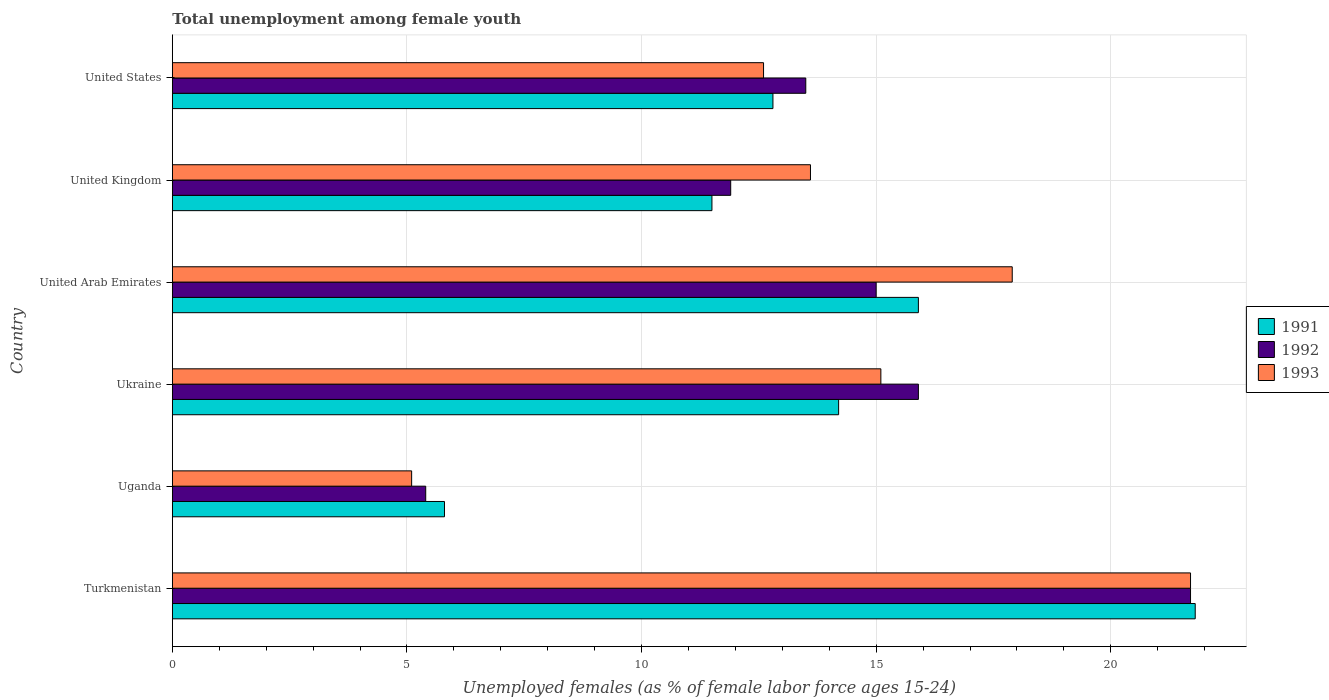Are the number of bars on each tick of the Y-axis equal?
Ensure brevity in your answer.  Yes. How many bars are there on the 5th tick from the bottom?
Give a very brief answer. 3. What is the percentage of unemployed females in in 1993 in Uganda?
Your answer should be compact. 5.1. Across all countries, what is the maximum percentage of unemployed females in in 1992?
Provide a short and direct response. 21.7. Across all countries, what is the minimum percentage of unemployed females in in 1992?
Your answer should be compact. 5.4. In which country was the percentage of unemployed females in in 1991 maximum?
Keep it short and to the point. Turkmenistan. In which country was the percentage of unemployed females in in 1991 minimum?
Provide a short and direct response. Uganda. What is the total percentage of unemployed females in in 1991 in the graph?
Keep it short and to the point. 82. What is the difference between the percentage of unemployed females in in 1992 in Turkmenistan and that in United Arab Emirates?
Keep it short and to the point. 6.7. What is the difference between the percentage of unemployed females in in 1992 in Uganda and the percentage of unemployed females in in 1991 in United Arab Emirates?
Offer a terse response. -10.5. What is the average percentage of unemployed females in in 1992 per country?
Make the answer very short. 13.9. What is the difference between the percentage of unemployed females in in 1991 and percentage of unemployed females in in 1993 in Ukraine?
Ensure brevity in your answer.  -0.9. In how many countries, is the percentage of unemployed females in in 1992 greater than 18 %?
Provide a short and direct response. 1. What is the ratio of the percentage of unemployed females in in 1991 in Ukraine to that in United States?
Your answer should be compact. 1.11. Is the percentage of unemployed females in in 1991 in Uganda less than that in United States?
Make the answer very short. Yes. What is the difference between the highest and the second highest percentage of unemployed females in in 1992?
Keep it short and to the point. 5.8. What is the difference between the highest and the lowest percentage of unemployed females in in 1991?
Keep it short and to the point. 16. In how many countries, is the percentage of unemployed females in in 1992 greater than the average percentage of unemployed females in in 1992 taken over all countries?
Your response must be concise. 3. What does the 3rd bar from the bottom in Uganda represents?
Offer a terse response. 1993. Is it the case that in every country, the sum of the percentage of unemployed females in in 1992 and percentage of unemployed females in in 1991 is greater than the percentage of unemployed females in in 1993?
Your answer should be very brief. Yes. How many bars are there?
Give a very brief answer. 18. How many countries are there in the graph?
Your response must be concise. 6. Does the graph contain any zero values?
Offer a terse response. No. How many legend labels are there?
Your response must be concise. 3. How are the legend labels stacked?
Offer a terse response. Vertical. What is the title of the graph?
Give a very brief answer. Total unemployment among female youth. What is the label or title of the X-axis?
Ensure brevity in your answer.  Unemployed females (as % of female labor force ages 15-24). What is the label or title of the Y-axis?
Make the answer very short. Country. What is the Unemployed females (as % of female labor force ages 15-24) of 1991 in Turkmenistan?
Ensure brevity in your answer.  21.8. What is the Unemployed females (as % of female labor force ages 15-24) in 1992 in Turkmenistan?
Your response must be concise. 21.7. What is the Unemployed females (as % of female labor force ages 15-24) of 1993 in Turkmenistan?
Make the answer very short. 21.7. What is the Unemployed females (as % of female labor force ages 15-24) in 1991 in Uganda?
Offer a very short reply. 5.8. What is the Unemployed females (as % of female labor force ages 15-24) in 1992 in Uganda?
Offer a very short reply. 5.4. What is the Unemployed females (as % of female labor force ages 15-24) of 1993 in Uganda?
Provide a short and direct response. 5.1. What is the Unemployed females (as % of female labor force ages 15-24) of 1991 in Ukraine?
Offer a very short reply. 14.2. What is the Unemployed females (as % of female labor force ages 15-24) in 1992 in Ukraine?
Provide a succinct answer. 15.9. What is the Unemployed females (as % of female labor force ages 15-24) of 1993 in Ukraine?
Provide a short and direct response. 15.1. What is the Unemployed females (as % of female labor force ages 15-24) in 1991 in United Arab Emirates?
Offer a terse response. 15.9. What is the Unemployed females (as % of female labor force ages 15-24) of 1992 in United Arab Emirates?
Offer a terse response. 15. What is the Unemployed females (as % of female labor force ages 15-24) in 1993 in United Arab Emirates?
Provide a short and direct response. 17.9. What is the Unemployed females (as % of female labor force ages 15-24) in 1992 in United Kingdom?
Give a very brief answer. 11.9. What is the Unemployed females (as % of female labor force ages 15-24) of 1993 in United Kingdom?
Ensure brevity in your answer.  13.6. What is the Unemployed females (as % of female labor force ages 15-24) of 1991 in United States?
Give a very brief answer. 12.8. What is the Unemployed females (as % of female labor force ages 15-24) in 1992 in United States?
Give a very brief answer. 13.5. What is the Unemployed females (as % of female labor force ages 15-24) in 1993 in United States?
Offer a very short reply. 12.6. Across all countries, what is the maximum Unemployed females (as % of female labor force ages 15-24) of 1991?
Offer a very short reply. 21.8. Across all countries, what is the maximum Unemployed females (as % of female labor force ages 15-24) of 1992?
Keep it short and to the point. 21.7. Across all countries, what is the maximum Unemployed females (as % of female labor force ages 15-24) in 1993?
Provide a succinct answer. 21.7. Across all countries, what is the minimum Unemployed females (as % of female labor force ages 15-24) of 1991?
Make the answer very short. 5.8. Across all countries, what is the minimum Unemployed females (as % of female labor force ages 15-24) in 1992?
Provide a succinct answer. 5.4. Across all countries, what is the minimum Unemployed females (as % of female labor force ages 15-24) of 1993?
Your answer should be very brief. 5.1. What is the total Unemployed females (as % of female labor force ages 15-24) of 1992 in the graph?
Make the answer very short. 83.4. What is the difference between the Unemployed females (as % of female labor force ages 15-24) of 1991 in Turkmenistan and that in Uganda?
Your answer should be very brief. 16. What is the difference between the Unemployed females (as % of female labor force ages 15-24) of 1992 in Turkmenistan and that in Uganda?
Make the answer very short. 16.3. What is the difference between the Unemployed females (as % of female labor force ages 15-24) of 1992 in Turkmenistan and that in Ukraine?
Give a very brief answer. 5.8. What is the difference between the Unemployed females (as % of female labor force ages 15-24) in 1993 in Turkmenistan and that in Ukraine?
Your response must be concise. 6.6. What is the difference between the Unemployed females (as % of female labor force ages 15-24) of 1991 in Turkmenistan and that in United Arab Emirates?
Offer a terse response. 5.9. What is the difference between the Unemployed females (as % of female labor force ages 15-24) in 1992 in Turkmenistan and that in United Arab Emirates?
Provide a succinct answer. 6.7. What is the difference between the Unemployed females (as % of female labor force ages 15-24) of 1991 in Turkmenistan and that in United Kingdom?
Offer a very short reply. 10.3. What is the difference between the Unemployed females (as % of female labor force ages 15-24) in 1992 in Turkmenistan and that in United Kingdom?
Ensure brevity in your answer.  9.8. What is the difference between the Unemployed females (as % of female labor force ages 15-24) in 1993 in Turkmenistan and that in United Kingdom?
Make the answer very short. 8.1. What is the difference between the Unemployed females (as % of female labor force ages 15-24) in 1991 in Uganda and that in Ukraine?
Your answer should be compact. -8.4. What is the difference between the Unemployed females (as % of female labor force ages 15-24) in 1993 in Uganda and that in United Arab Emirates?
Keep it short and to the point. -12.8. What is the difference between the Unemployed females (as % of female labor force ages 15-24) of 1992 in Ukraine and that in United Kingdom?
Your answer should be very brief. 4. What is the difference between the Unemployed females (as % of female labor force ages 15-24) in 1993 in Ukraine and that in United Kingdom?
Your answer should be very brief. 1.5. What is the difference between the Unemployed females (as % of female labor force ages 15-24) in 1992 in Ukraine and that in United States?
Offer a very short reply. 2.4. What is the difference between the Unemployed females (as % of female labor force ages 15-24) of 1993 in Ukraine and that in United States?
Provide a succinct answer. 2.5. What is the difference between the Unemployed females (as % of female labor force ages 15-24) in 1991 in United Arab Emirates and that in United Kingdom?
Offer a terse response. 4.4. What is the difference between the Unemployed females (as % of female labor force ages 15-24) in 1992 in United Arab Emirates and that in United Kingdom?
Ensure brevity in your answer.  3.1. What is the difference between the Unemployed females (as % of female labor force ages 15-24) in 1991 in United Arab Emirates and that in United States?
Make the answer very short. 3.1. What is the difference between the Unemployed females (as % of female labor force ages 15-24) in 1992 in United Arab Emirates and that in United States?
Make the answer very short. 1.5. What is the difference between the Unemployed females (as % of female labor force ages 15-24) of 1993 in United Arab Emirates and that in United States?
Ensure brevity in your answer.  5.3. What is the difference between the Unemployed females (as % of female labor force ages 15-24) of 1992 in United Kingdom and that in United States?
Your response must be concise. -1.6. What is the difference between the Unemployed females (as % of female labor force ages 15-24) in 1993 in United Kingdom and that in United States?
Offer a terse response. 1. What is the difference between the Unemployed females (as % of female labor force ages 15-24) of 1991 in Turkmenistan and the Unemployed females (as % of female labor force ages 15-24) of 1992 in Uganda?
Provide a succinct answer. 16.4. What is the difference between the Unemployed females (as % of female labor force ages 15-24) of 1992 in Turkmenistan and the Unemployed females (as % of female labor force ages 15-24) of 1993 in Uganda?
Your response must be concise. 16.6. What is the difference between the Unemployed females (as % of female labor force ages 15-24) in 1991 in Turkmenistan and the Unemployed females (as % of female labor force ages 15-24) in 1992 in Ukraine?
Offer a very short reply. 5.9. What is the difference between the Unemployed females (as % of female labor force ages 15-24) of 1991 in Turkmenistan and the Unemployed females (as % of female labor force ages 15-24) of 1993 in Ukraine?
Offer a very short reply. 6.7. What is the difference between the Unemployed females (as % of female labor force ages 15-24) in 1992 in Turkmenistan and the Unemployed females (as % of female labor force ages 15-24) in 1993 in Ukraine?
Your answer should be compact. 6.6. What is the difference between the Unemployed females (as % of female labor force ages 15-24) in 1991 in Turkmenistan and the Unemployed females (as % of female labor force ages 15-24) in 1992 in United Arab Emirates?
Provide a succinct answer. 6.8. What is the difference between the Unemployed females (as % of female labor force ages 15-24) in 1991 in Turkmenistan and the Unemployed females (as % of female labor force ages 15-24) in 1993 in United Arab Emirates?
Your response must be concise. 3.9. What is the difference between the Unemployed females (as % of female labor force ages 15-24) of 1992 in Turkmenistan and the Unemployed females (as % of female labor force ages 15-24) of 1993 in United Arab Emirates?
Provide a short and direct response. 3.8. What is the difference between the Unemployed females (as % of female labor force ages 15-24) in 1991 in Turkmenistan and the Unemployed females (as % of female labor force ages 15-24) in 1993 in United States?
Ensure brevity in your answer.  9.2. What is the difference between the Unemployed females (as % of female labor force ages 15-24) in 1992 in Turkmenistan and the Unemployed females (as % of female labor force ages 15-24) in 1993 in United States?
Your answer should be compact. 9.1. What is the difference between the Unemployed females (as % of female labor force ages 15-24) of 1991 in Uganda and the Unemployed females (as % of female labor force ages 15-24) of 1992 in Ukraine?
Your answer should be compact. -10.1. What is the difference between the Unemployed females (as % of female labor force ages 15-24) of 1992 in Uganda and the Unemployed females (as % of female labor force ages 15-24) of 1993 in Ukraine?
Your answer should be very brief. -9.7. What is the difference between the Unemployed females (as % of female labor force ages 15-24) of 1991 in Uganda and the Unemployed females (as % of female labor force ages 15-24) of 1992 in United Arab Emirates?
Give a very brief answer. -9.2. What is the difference between the Unemployed females (as % of female labor force ages 15-24) in 1991 in Uganda and the Unemployed females (as % of female labor force ages 15-24) in 1992 in United Kingdom?
Provide a succinct answer. -6.1. What is the difference between the Unemployed females (as % of female labor force ages 15-24) in 1991 in Uganda and the Unemployed females (as % of female labor force ages 15-24) in 1993 in United Kingdom?
Offer a very short reply. -7.8. What is the difference between the Unemployed females (as % of female labor force ages 15-24) of 1991 in Uganda and the Unemployed females (as % of female labor force ages 15-24) of 1992 in United States?
Offer a very short reply. -7.7. What is the difference between the Unemployed females (as % of female labor force ages 15-24) in 1992 in Uganda and the Unemployed females (as % of female labor force ages 15-24) in 1993 in United States?
Offer a very short reply. -7.2. What is the difference between the Unemployed females (as % of female labor force ages 15-24) of 1992 in Ukraine and the Unemployed females (as % of female labor force ages 15-24) of 1993 in United Arab Emirates?
Make the answer very short. -2. What is the difference between the Unemployed females (as % of female labor force ages 15-24) in 1992 in Ukraine and the Unemployed females (as % of female labor force ages 15-24) in 1993 in United Kingdom?
Offer a terse response. 2.3. What is the difference between the Unemployed females (as % of female labor force ages 15-24) in 1991 in Ukraine and the Unemployed females (as % of female labor force ages 15-24) in 1993 in United States?
Offer a terse response. 1.6. What is the difference between the Unemployed females (as % of female labor force ages 15-24) of 1991 in United Arab Emirates and the Unemployed females (as % of female labor force ages 15-24) of 1992 in United Kingdom?
Offer a very short reply. 4. What is the difference between the Unemployed females (as % of female labor force ages 15-24) in 1991 in United Arab Emirates and the Unemployed females (as % of female labor force ages 15-24) in 1993 in United Kingdom?
Give a very brief answer. 2.3. What is the difference between the Unemployed females (as % of female labor force ages 15-24) of 1991 in United Arab Emirates and the Unemployed females (as % of female labor force ages 15-24) of 1992 in United States?
Your response must be concise. 2.4. What is the difference between the Unemployed females (as % of female labor force ages 15-24) in 1992 in United Arab Emirates and the Unemployed females (as % of female labor force ages 15-24) in 1993 in United States?
Make the answer very short. 2.4. What is the difference between the Unemployed females (as % of female labor force ages 15-24) in 1992 in United Kingdom and the Unemployed females (as % of female labor force ages 15-24) in 1993 in United States?
Provide a short and direct response. -0.7. What is the average Unemployed females (as % of female labor force ages 15-24) of 1991 per country?
Ensure brevity in your answer.  13.67. What is the average Unemployed females (as % of female labor force ages 15-24) of 1992 per country?
Your answer should be very brief. 13.9. What is the average Unemployed females (as % of female labor force ages 15-24) of 1993 per country?
Offer a very short reply. 14.33. What is the difference between the Unemployed females (as % of female labor force ages 15-24) of 1991 and Unemployed females (as % of female labor force ages 15-24) of 1992 in Turkmenistan?
Give a very brief answer. 0.1. What is the difference between the Unemployed females (as % of female labor force ages 15-24) in 1991 and Unemployed females (as % of female labor force ages 15-24) in 1993 in Turkmenistan?
Offer a terse response. 0.1. What is the difference between the Unemployed females (as % of female labor force ages 15-24) of 1991 and Unemployed females (as % of female labor force ages 15-24) of 1992 in Uganda?
Make the answer very short. 0.4. What is the difference between the Unemployed females (as % of female labor force ages 15-24) in 1991 and Unemployed females (as % of female labor force ages 15-24) in 1993 in Uganda?
Offer a very short reply. 0.7. What is the difference between the Unemployed females (as % of female labor force ages 15-24) of 1991 and Unemployed females (as % of female labor force ages 15-24) of 1993 in Ukraine?
Keep it short and to the point. -0.9. What is the difference between the Unemployed females (as % of female labor force ages 15-24) in 1991 and Unemployed females (as % of female labor force ages 15-24) in 1992 in United Arab Emirates?
Provide a short and direct response. 0.9. What is the difference between the Unemployed females (as % of female labor force ages 15-24) in 1991 and Unemployed females (as % of female labor force ages 15-24) in 1993 in United Arab Emirates?
Offer a terse response. -2. What is the difference between the Unemployed females (as % of female labor force ages 15-24) of 1992 and Unemployed females (as % of female labor force ages 15-24) of 1993 in United States?
Give a very brief answer. 0.9. What is the ratio of the Unemployed females (as % of female labor force ages 15-24) of 1991 in Turkmenistan to that in Uganda?
Give a very brief answer. 3.76. What is the ratio of the Unemployed females (as % of female labor force ages 15-24) in 1992 in Turkmenistan to that in Uganda?
Keep it short and to the point. 4.02. What is the ratio of the Unemployed females (as % of female labor force ages 15-24) of 1993 in Turkmenistan to that in Uganda?
Provide a succinct answer. 4.25. What is the ratio of the Unemployed females (as % of female labor force ages 15-24) in 1991 in Turkmenistan to that in Ukraine?
Your response must be concise. 1.54. What is the ratio of the Unemployed females (as % of female labor force ages 15-24) in 1992 in Turkmenistan to that in Ukraine?
Ensure brevity in your answer.  1.36. What is the ratio of the Unemployed females (as % of female labor force ages 15-24) in 1993 in Turkmenistan to that in Ukraine?
Make the answer very short. 1.44. What is the ratio of the Unemployed females (as % of female labor force ages 15-24) in 1991 in Turkmenistan to that in United Arab Emirates?
Make the answer very short. 1.37. What is the ratio of the Unemployed females (as % of female labor force ages 15-24) in 1992 in Turkmenistan to that in United Arab Emirates?
Your answer should be very brief. 1.45. What is the ratio of the Unemployed females (as % of female labor force ages 15-24) of 1993 in Turkmenistan to that in United Arab Emirates?
Keep it short and to the point. 1.21. What is the ratio of the Unemployed females (as % of female labor force ages 15-24) of 1991 in Turkmenistan to that in United Kingdom?
Provide a succinct answer. 1.9. What is the ratio of the Unemployed females (as % of female labor force ages 15-24) of 1992 in Turkmenistan to that in United Kingdom?
Make the answer very short. 1.82. What is the ratio of the Unemployed females (as % of female labor force ages 15-24) of 1993 in Turkmenistan to that in United Kingdom?
Offer a terse response. 1.6. What is the ratio of the Unemployed females (as % of female labor force ages 15-24) in 1991 in Turkmenistan to that in United States?
Offer a terse response. 1.7. What is the ratio of the Unemployed females (as % of female labor force ages 15-24) in 1992 in Turkmenistan to that in United States?
Give a very brief answer. 1.61. What is the ratio of the Unemployed females (as % of female labor force ages 15-24) of 1993 in Turkmenistan to that in United States?
Offer a very short reply. 1.72. What is the ratio of the Unemployed females (as % of female labor force ages 15-24) of 1991 in Uganda to that in Ukraine?
Keep it short and to the point. 0.41. What is the ratio of the Unemployed females (as % of female labor force ages 15-24) in 1992 in Uganda to that in Ukraine?
Your answer should be very brief. 0.34. What is the ratio of the Unemployed females (as % of female labor force ages 15-24) in 1993 in Uganda to that in Ukraine?
Your response must be concise. 0.34. What is the ratio of the Unemployed females (as % of female labor force ages 15-24) in 1991 in Uganda to that in United Arab Emirates?
Keep it short and to the point. 0.36. What is the ratio of the Unemployed females (as % of female labor force ages 15-24) of 1992 in Uganda to that in United Arab Emirates?
Make the answer very short. 0.36. What is the ratio of the Unemployed females (as % of female labor force ages 15-24) of 1993 in Uganda to that in United Arab Emirates?
Ensure brevity in your answer.  0.28. What is the ratio of the Unemployed females (as % of female labor force ages 15-24) of 1991 in Uganda to that in United Kingdom?
Offer a terse response. 0.5. What is the ratio of the Unemployed females (as % of female labor force ages 15-24) in 1992 in Uganda to that in United Kingdom?
Provide a short and direct response. 0.45. What is the ratio of the Unemployed females (as % of female labor force ages 15-24) of 1993 in Uganda to that in United Kingdom?
Provide a succinct answer. 0.38. What is the ratio of the Unemployed females (as % of female labor force ages 15-24) in 1991 in Uganda to that in United States?
Keep it short and to the point. 0.45. What is the ratio of the Unemployed females (as % of female labor force ages 15-24) of 1993 in Uganda to that in United States?
Provide a succinct answer. 0.4. What is the ratio of the Unemployed females (as % of female labor force ages 15-24) in 1991 in Ukraine to that in United Arab Emirates?
Make the answer very short. 0.89. What is the ratio of the Unemployed females (as % of female labor force ages 15-24) in 1992 in Ukraine to that in United Arab Emirates?
Give a very brief answer. 1.06. What is the ratio of the Unemployed females (as % of female labor force ages 15-24) in 1993 in Ukraine to that in United Arab Emirates?
Your answer should be very brief. 0.84. What is the ratio of the Unemployed females (as % of female labor force ages 15-24) of 1991 in Ukraine to that in United Kingdom?
Provide a short and direct response. 1.23. What is the ratio of the Unemployed females (as % of female labor force ages 15-24) of 1992 in Ukraine to that in United Kingdom?
Ensure brevity in your answer.  1.34. What is the ratio of the Unemployed females (as % of female labor force ages 15-24) of 1993 in Ukraine to that in United Kingdom?
Your answer should be compact. 1.11. What is the ratio of the Unemployed females (as % of female labor force ages 15-24) in 1991 in Ukraine to that in United States?
Give a very brief answer. 1.11. What is the ratio of the Unemployed females (as % of female labor force ages 15-24) of 1992 in Ukraine to that in United States?
Keep it short and to the point. 1.18. What is the ratio of the Unemployed females (as % of female labor force ages 15-24) of 1993 in Ukraine to that in United States?
Offer a terse response. 1.2. What is the ratio of the Unemployed females (as % of female labor force ages 15-24) in 1991 in United Arab Emirates to that in United Kingdom?
Provide a short and direct response. 1.38. What is the ratio of the Unemployed females (as % of female labor force ages 15-24) in 1992 in United Arab Emirates to that in United Kingdom?
Provide a succinct answer. 1.26. What is the ratio of the Unemployed females (as % of female labor force ages 15-24) in 1993 in United Arab Emirates to that in United Kingdom?
Ensure brevity in your answer.  1.32. What is the ratio of the Unemployed females (as % of female labor force ages 15-24) in 1991 in United Arab Emirates to that in United States?
Provide a succinct answer. 1.24. What is the ratio of the Unemployed females (as % of female labor force ages 15-24) of 1992 in United Arab Emirates to that in United States?
Your answer should be compact. 1.11. What is the ratio of the Unemployed females (as % of female labor force ages 15-24) of 1993 in United Arab Emirates to that in United States?
Give a very brief answer. 1.42. What is the ratio of the Unemployed females (as % of female labor force ages 15-24) in 1991 in United Kingdom to that in United States?
Provide a succinct answer. 0.9. What is the ratio of the Unemployed females (as % of female labor force ages 15-24) in 1992 in United Kingdom to that in United States?
Ensure brevity in your answer.  0.88. What is the ratio of the Unemployed females (as % of female labor force ages 15-24) of 1993 in United Kingdom to that in United States?
Your answer should be very brief. 1.08. What is the difference between the highest and the second highest Unemployed females (as % of female labor force ages 15-24) in 1991?
Your response must be concise. 5.9. What is the difference between the highest and the second highest Unemployed females (as % of female labor force ages 15-24) of 1992?
Provide a short and direct response. 5.8. What is the difference between the highest and the lowest Unemployed females (as % of female labor force ages 15-24) in 1991?
Ensure brevity in your answer.  16. What is the difference between the highest and the lowest Unemployed females (as % of female labor force ages 15-24) of 1993?
Make the answer very short. 16.6. 